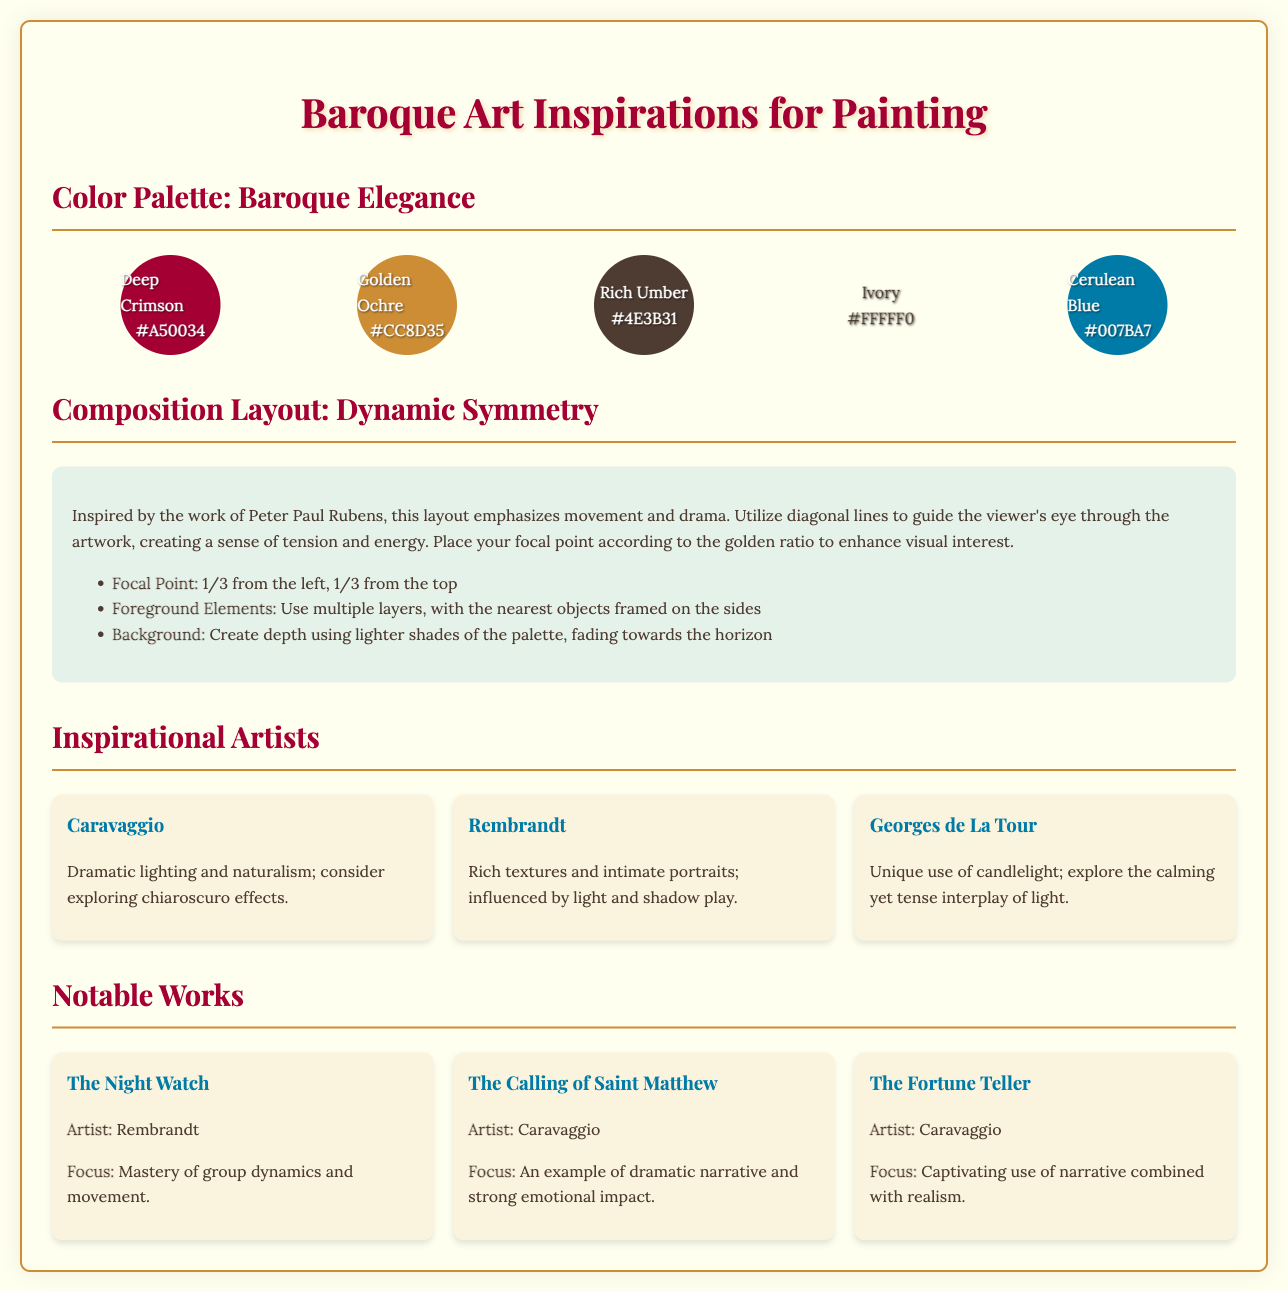What are the colors in the color palette? The document lists five colors in the color palette, which are Deep Crimson, Golden Ochre, Rich Umber, Ivory, and Cerulean Blue.
Answer: Deep Crimson, Golden Ochre, Rich Umber, Ivory, Cerulean Blue What is the focal point location in the composition? The document specifies the focal point location as 1/3 from the left and 1/3 from the top of the painting.
Answer: 1/3 from the left, 1/3 from the top Which artist is known for dramatic lighting? Caravaggio is mentioned in the document as an artist known for his dramatic lighting and naturalism.
Answer: Caravaggio What type of layout is suggested for the composition? The document suggests a layout emphasizing dynamic symmetry inspired by Peter Paul Rubens.
Answer: Dynamic Symmetry What is the hex code for Cerulean Blue? The hex code corresponding to Cerulean Blue in the color palette is provided in the document.
Answer: #007BA7 Which artwork is noted for mastery of group dynamics? The Night Watch by Rembrandt is highlighted in the document for its mastery of group dynamics and movement.
Answer: The Night Watch How many colors are in the color palette? The document contains a color palette consisting of five distinct colors.
Answer: Five What does the document suggest for the background elements? The document advises creating depth in the background using lighter shades of the palette.
Answer: Lighter shades 